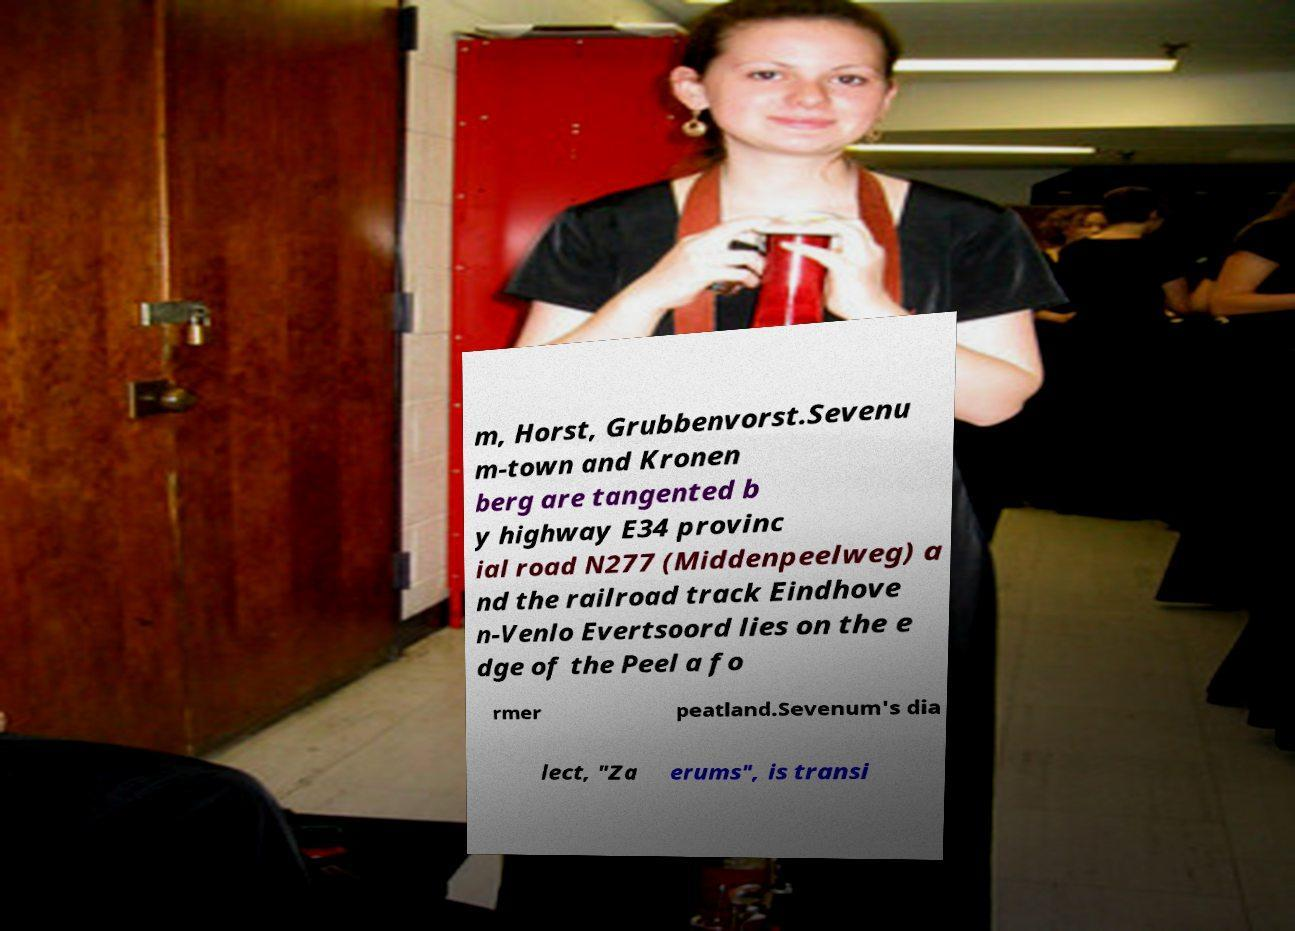Could you assist in decoding the text presented in this image and type it out clearly? m, Horst, Grubbenvorst.Sevenu m-town and Kronen berg are tangented b y highway E34 provinc ial road N277 (Middenpeelweg) a nd the railroad track Eindhove n-Venlo Evertsoord lies on the e dge of the Peel a fo rmer peatland.Sevenum's dia lect, "Za erums", is transi 